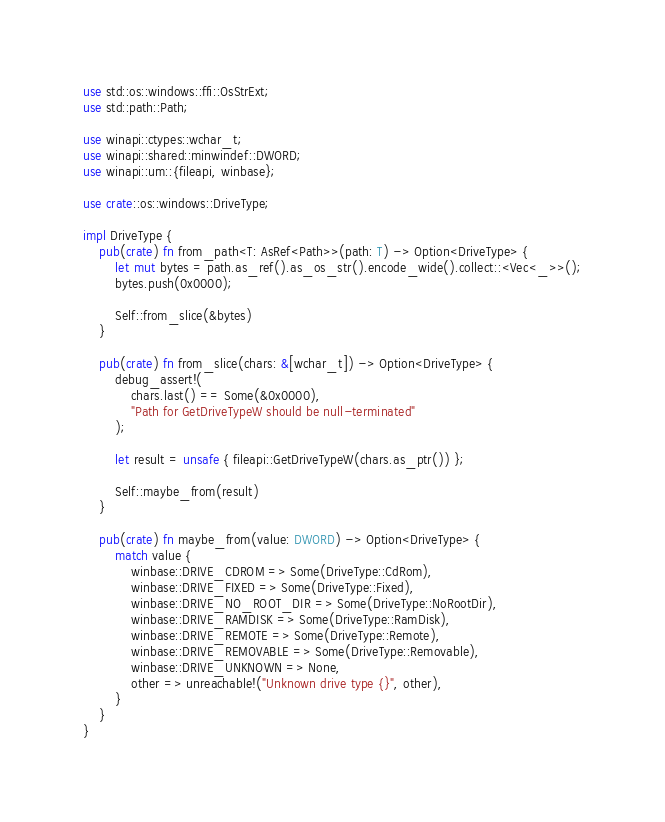<code> <loc_0><loc_0><loc_500><loc_500><_Rust_>use std::os::windows::ffi::OsStrExt;
use std::path::Path;

use winapi::ctypes::wchar_t;
use winapi::shared::minwindef::DWORD;
use winapi::um::{fileapi, winbase};

use crate::os::windows::DriveType;

impl DriveType {
    pub(crate) fn from_path<T: AsRef<Path>>(path: T) -> Option<DriveType> {
        let mut bytes = path.as_ref().as_os_str().encode_wide().collect::<Vec<_>>();
        bytes.push(0x0000);

        Self::from_slice(&bytes)
    }

    pub(crate) fn from_slice(chars: &[wchar_t]) -> Option<DriveType> {
        debug_assert!(
            chars.last() == Some(&0x0000),
            "Path for GetDriveTypeW should be null-terminated"
        );

        let result = unsafe { fileapi::GetDriveTypeW(chars.as_ptr()) };

        Self::maybe_from(result)
    }

    pub(crate) fn maybe_from(value: DWORD) -> Option<DriveType> {
        match value {
            winbase::DRIVE_CDROM => Some(DriveType::CdRom),
            winbase::DRIVE_FIXED => Some(DriveType::Fixed),
            winbase::DRIVE_NO_ROOT_DIR => Some(DriveType::NoRootDir),
            winbase::DRIVE_RAMDISK => Some(DriveType::RamDisk),
            winbase::DRIVE_REMOTE => Some(DriveType::Remote),
            winbase::DRIVE_REMOVABLE => Some(DriveType::Removable),
            winbase::DRIVE_UNKNOWN => None,
            other => unreachable!("Unknown drive type {}", other),
        }
    }
}
</code> 